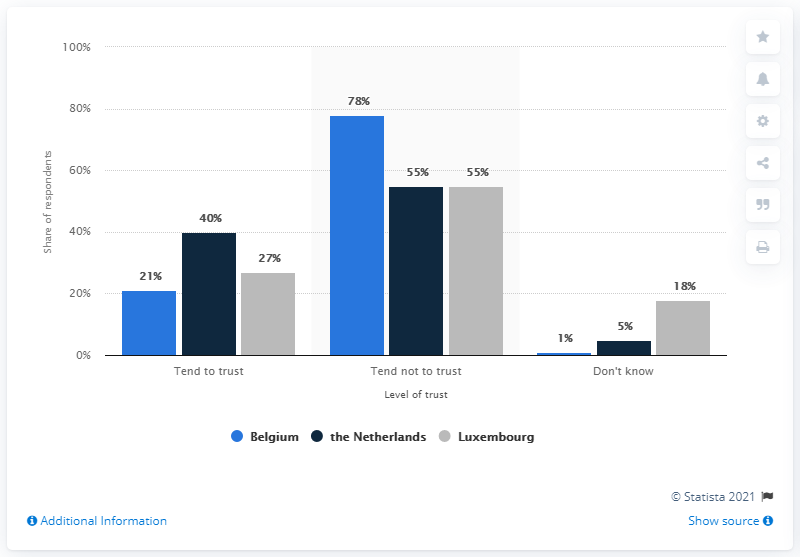Highlight a few significant elements in this photo. The average of "tend not to trust" is approximately 62.67. According to the survey, 40% of Dutch respondents tended to trust political parties. The sentence "How many countries are represented on this graph? 3.." is a question asking for information about the number of countries represented in a graph. 